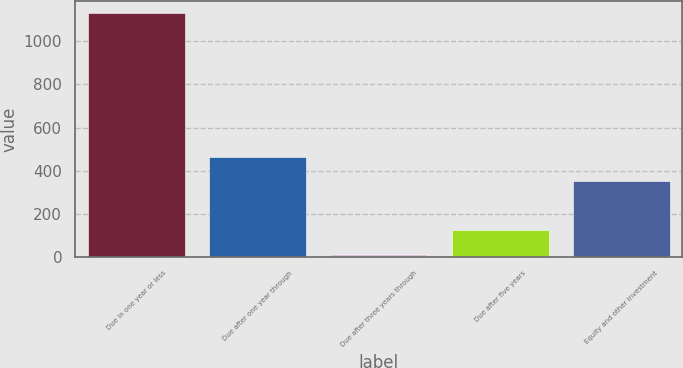<chart> <loc_0><loc_0><loc_500><loc_500><bar_chart><fcel>Due in one year or less<fcel>Due after one year through<fcel>Due after three years through<fcel>Due after five years<fcel>Equity and other investment<nl><fcel>1131<fcel>464.6<fcel>15<fcel>126.6<fcel>353<nl></chart> 